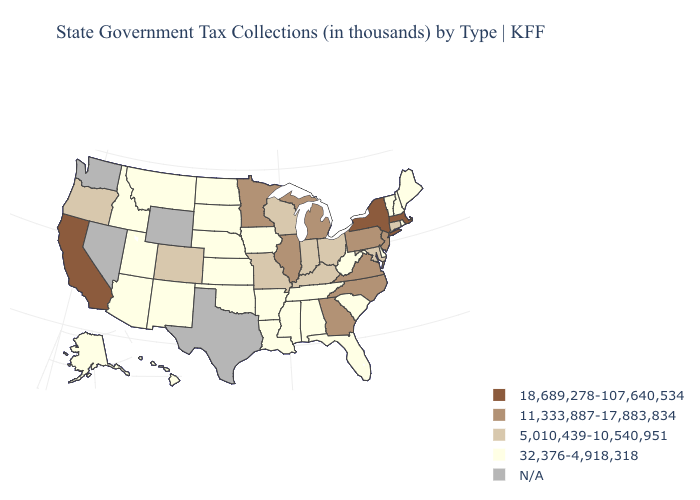What is the highest value in the MidWest ?
Short answer required. 11,333,887-17,883,834. Name the states that have a value in the range 11,333,887-17,883,834?
Be succinct. Georgia, Illinois, Michigan, Minnesota, New Jersey, North Carolina, Pennsylvania, Virginia. What is the highest value in the South ?
Short answer required. 11,333,887-17,883,834. What is the value of Oregon?
Answer briefly. 5,010,439-10,540,951. Name the states that have a value in the range 5,010,439-10,540,951?
Short answer required. Colorado, Connecticut, Indiana, Kentucky, Maryland, Missouri, Ohio, Oregon, Wisconsin. What is the value of Idaho?
Give a very brief answer. 32,376-4,918,318. What is the highest value in the USA?
Give a very brief answer. 18,689,278-107,640,534. What is the value of Indiana?
Write a very short answer. 5,010,439-10,540,951. Name the states that have a value in the range 5,010,439-10,540,951?
Keep it brief. Colorado, Connecticut, Indiana, Kentucky, Maryland, Missouri, Ohio, Oregon, Wisconsin. What is the value of Georgia?
Keep it brief. 11,333,887-17,883,834. What is the lowest value in the USA?
Answer briefly. 32,376-4,918,318. Does California have the highest value in the West?
Short answer required. Yes. What is the highest value in the USA?
Short answer required. 18,689,278-107,640,534. Does Kansas have the highest value in the MidWest?
Keep it brief. No. 